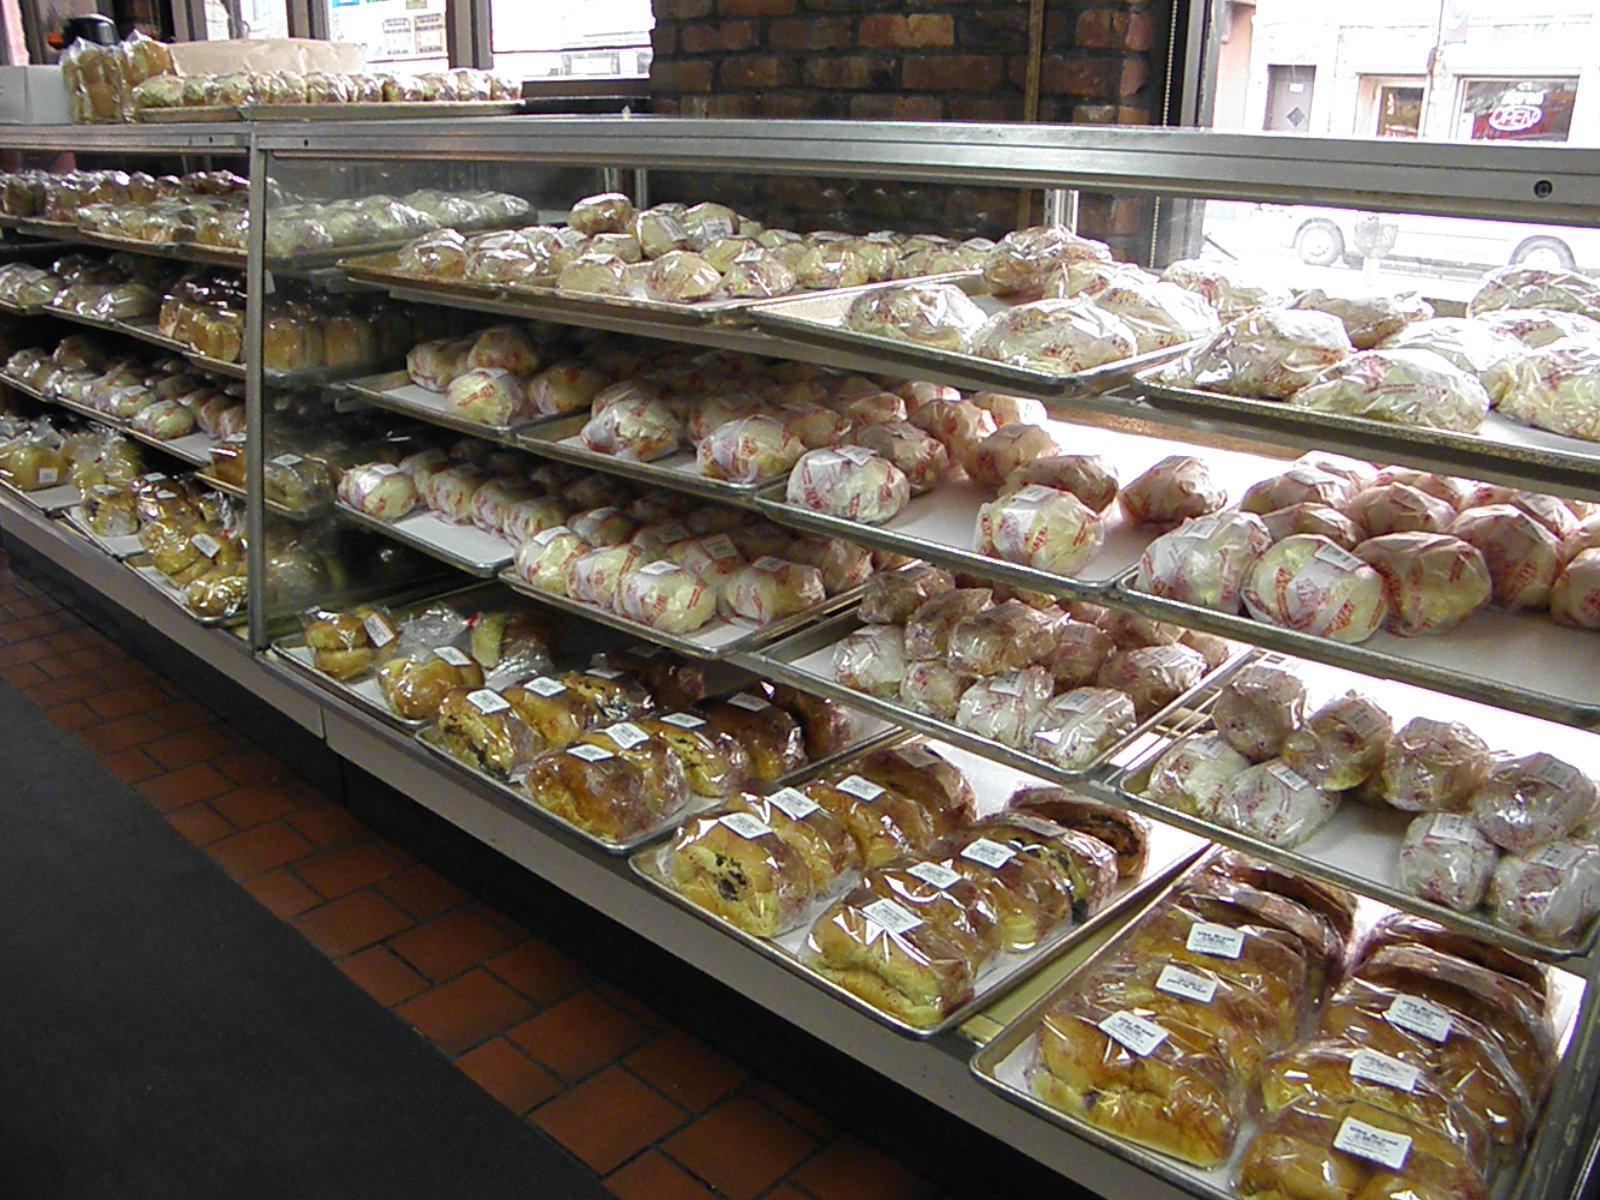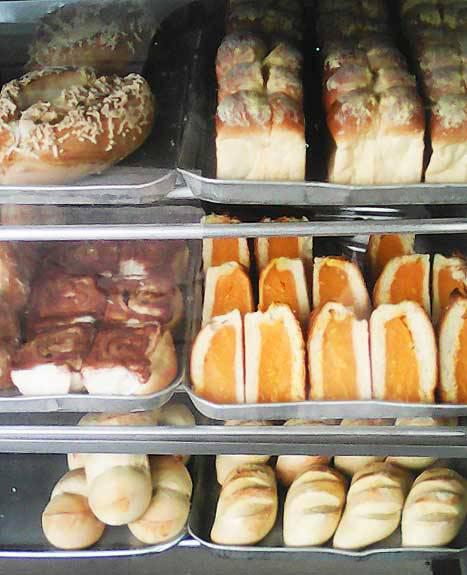The first image is the image on the left, the second image is the image on the right. For the images shown, is this caption "There are windows in one of the images." true? Answer yes or no. Yes. 